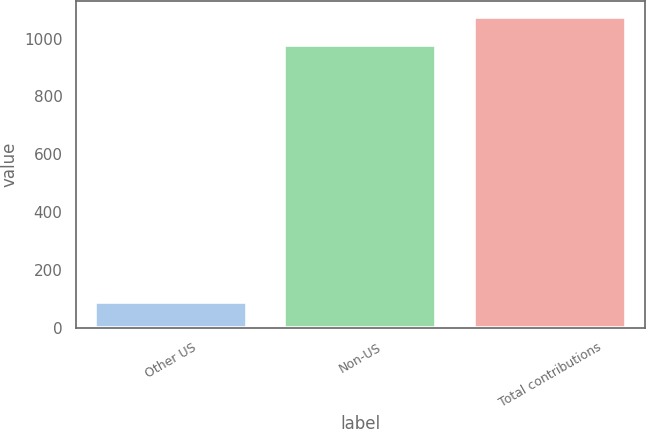<chart> <loc_0><loc_0><loc_500><loc_500><bar_chart><fcel>Other US<fcel>Non-US<fcel>Total contributions<nl><fcel>90<fcel>977<fcel>1074.7<nl></chart> 